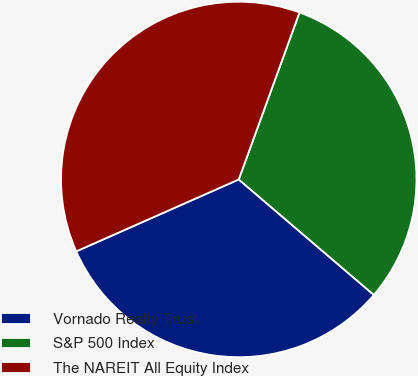<chart> <loc_0><loc_0><loc_500><loc_500><pie_chart><fcel>Vornado Realty Trust<fcel>S&P 500 Index<fcel>The NAREIT All Equity Index<nl><fcel>32.11%<fcel>30.7%<fcel>37.18%<nl></chart> 